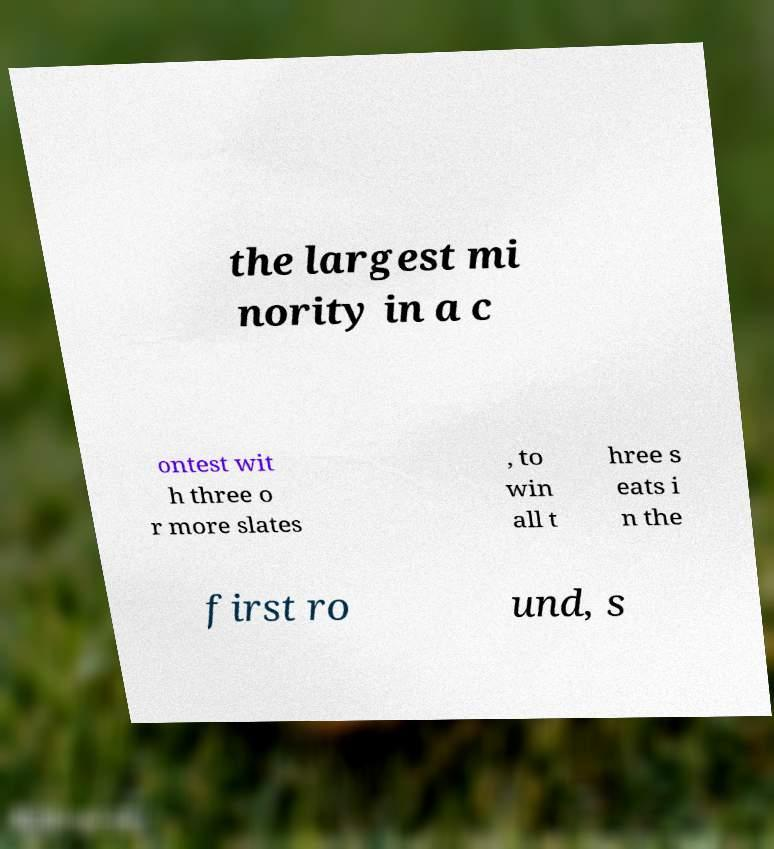Can you read and provide the text displayed in the image?This photo seems to have some interesting text. Can you extract and type it out for me? the largest mi nority in a c ontest wit h three o r more slates , to win all t hree s eats i n the first ro und, s 